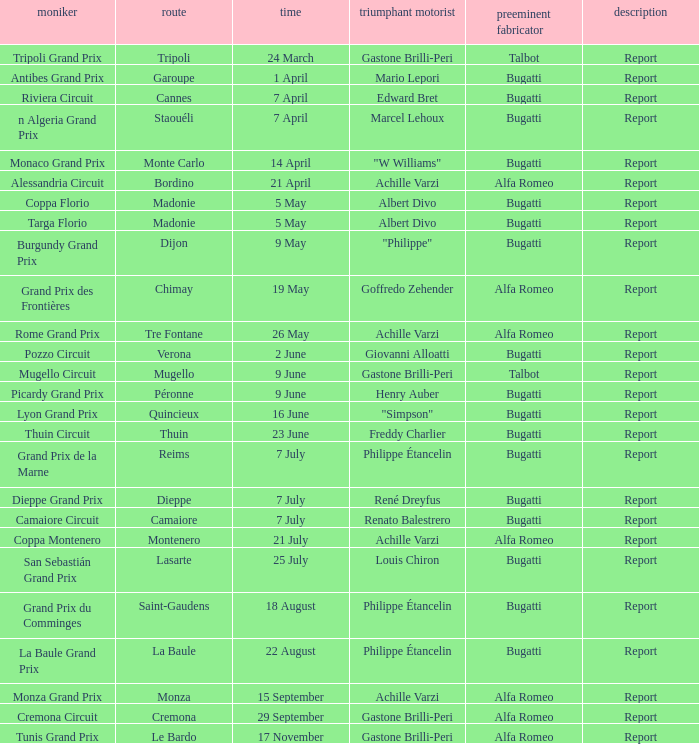What Name has a Winning constructor of bugatti, and a Winning driver of louis chiron? San Sebastián Grand Prix. 